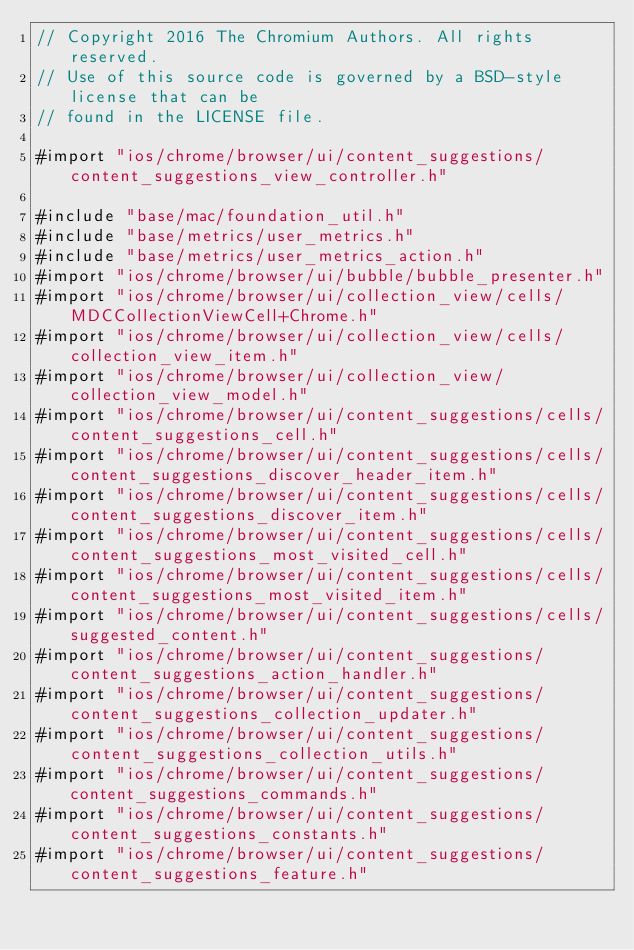Convert code to text. <code><loc_0><loc_0><loc_500><loc_500><_ObjectiveC_>// Copyright 2016 The Chromium Authors. All rights reserved.
// Use of this source code is governed by a BSD-style license that can be
// found in the LICENSE file.

#import "ios/chrome/browser/ui/content_suggestions/content_suggestions_view_controller.h"

#include "base/mac/foundation_util.h"
#include "base/metrics/user_metrics.h"
#include "base/metrics/user_metrics_action.h"
#import "ios/chrome/browser/ui/bubble/bubble_presenter.h"
#import "ios/chrome/browser/ui/collection_view/cells/MDCCollectionViewCell+Chrome.h"
#import "ios/chrome/browser/ui/collection_view/cells/collection_view_item.h"
#import "ios/chrome/browser/ui/collection_view/collection_view_model.h"
#import "ios/chrome/browser/ui/content_suggestions/cells/content_suggestions_cell.h"
#import "ios/chrome/browser/ui/content_suggestions/cells/content_suggestions_discover_header_item.h"
#import "ios/chrome/browser/ui/content_suggestions/cells/content_suggestions_discover_item.h"
#import "ios/chrome/browser/ui/content_suggestions/cells/content_suggestions_most_visited_cell.h"
#import "ios/chrome/browser/ui/content_suggestions/cells/content_suggestions_most_visited_item.h"
#import "ios/chrome/browser/ui/content_suggestions/cells/suggested_content.h"
#import "ios/chrome/browser/ui/content_suggestions/content_suggestions_action_handler.h"
#import "ios/chrome/browser/ui/content_suggestions/content_suggestions_collection_updater.h"
#import "ios/chrome/browser/ui/content_suggestions/content_suggestions_collection_utils.h"
#import "ios/chrome/browser/ui/content_suggestions/content_suggestions_commands.h"
#import "ios/chrome/browser/ui/content_suggestions/content_suggestions_constants.h"
#import "ios/chrome/browser/ui/content_suggestions/content_suggestions_feature.h"</code> 